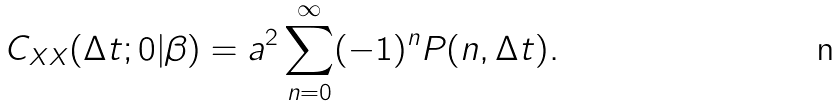<formula> <loc_0><loc_0><loc_500><loc_500>C _ { X X } ( \Delta t ; 0 | \beta ) = a ^ { 2 } \sum _ { n = 0 } ^ { \infty } ( - 1 ) ^ { n } P ( n , \Delta t ) .</formula> 